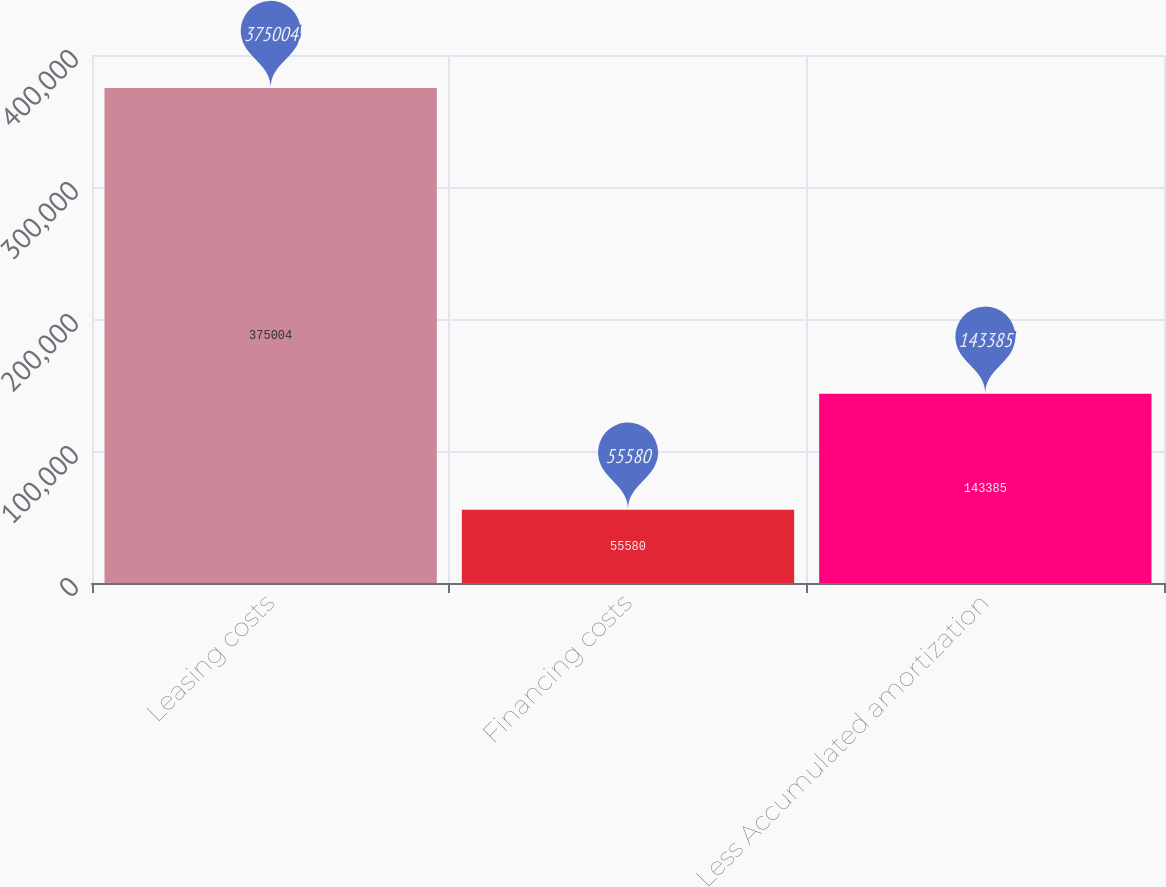Convert chart to OTSL. <chart><loc_0><loc_0><loc_500><loc_500><bar_chart><fcel>Leasing costs<fcel>Financing costs<fcel>Less Accumulated amortization<nl><fcel>375004<fcel>55580<fcel>143385<nl></chart> 